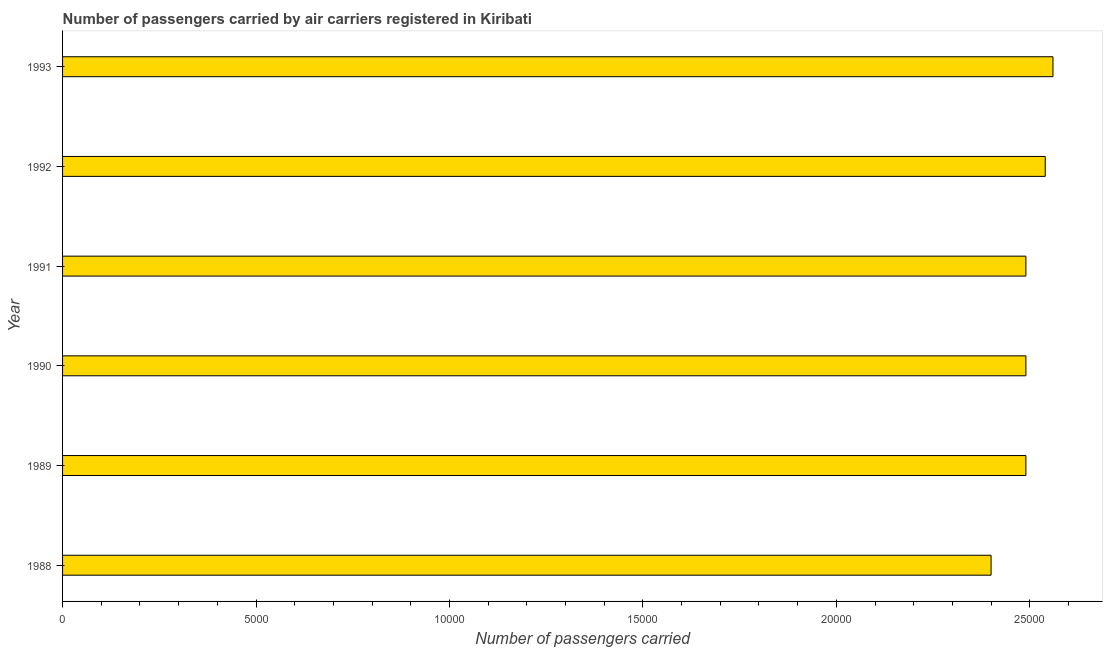Does the graph contain any zero values?
Your answer should be very brief. No. What is the title of the graph?
Provide a succinct answer. Number of passengers carried by air carriers registered in Kiribati. What is the label or title of the X-axis?
Your answer should be very brief. Number of passengers carried. What is the number of passengers carried in 1990?
Offer a very short reply. 2.49e+04. Across all years, what is the maximum number of passengers carried?
Give a very brief answer. 2.56e+04. Across all years, what is the minimum number of passengers carried?
Offer a very short reply. 2.40e+04. In which year was the number of passengers carried maximum?
Make the answer very short. 1993. What is the sum of the number of passengers carried?
Offer a terse response. 1.50e+05. What is the difference between the number of passengers carried in 1992 and 1993?
Offer a terse response. -200. What is the average number of passengers carried per year?
Provide a short and direct response. 2.50e+04. What is the median number of passengers carried?
Offer a terse response. 2.49e+04. In how many years, is the number of passengers carried greater than 11000 ?
Keep it short and to the point. 6. Is the number of passengers carried in 1989 less than that in 1992?
Make the answer very short. Yes. What is the difference between the highest and the lowest number of passengers carried?
Offer a very short reply. 1600. In how many years, is the number of passengers carried greater than the average number of passengers carried taken over all years?
Your response must be concise. 2. What is the difference between two consecutive major ticks on the X-axis?
Your answer should be compact. 5000. Are the values on the major ticks of X-axis written in scientific E-notation?
Provide a short and direct response. No. What is the Number of passengers carried of 1988?
Offer a very short reply. 2.40e+04. What is the Number of passengers carried in 1989?
Keep it short and to the point. 2.49e+04. What is the Number of passengers carried in 1990?
Make the answer very short. 2.49e+04. What is the Number of passengers carried of 1991?
Offer a very short reply. 2.49e+04. What is the Number of passengers carried in 1992?
Offer a very short reply. 2.54e+04. What is the Number of passengers carried of 1993?
Give a very brief answer. 2.56e+04. What is the difference between the Number of passengers carried in 1988 and 1989?
Your answer should be very brief. -900. What is the difference between the Number of passengers carried in 1988 and 1990?
Make the answer very short. -900. What is the difference between the Number of passengers carried in 1988 and 1991?
Provide a succinct answer. -900. What is the difference between the Number of passengers carried in 1988 and 1992?
Your response must be concise. -1400. What is the difference between the Number of passengers carried in 1988 and 1993?
Make the answer very short. -1600. What is the difference between the Number of passengers carried in 1989 and 1990?
Your answer should be compact. 0. What is the difference between the Number of passengers carried in 1989 and 1992?
Your response must be concise. -500. What is the difference between the Number of passengers carried in 1989 and 1993?
Make the answer very short. -700. What is the difference between the Number of passengers carried in 1990 and 1992?
Provide a short and direct response. -500. What is the difference between the Number of passengers carried in 1990 and 1993?
Your response must be concise. -700. What is the difference between the Number of passengers carried in 1991 and 1992?
Your answer should be very brief. -500. What is the difference between the Number of passengers carried in 1991 and 1993?
Your answer should be compact. -700. What is the difference between the Number of passengers carried in 1992 and 1993?
Make the answer very short. -200. What is the ratio of the Number of passengers carried in 1988 to that in 1989?
Your response must be concise. 0.96. What is the ratio of the Number of passengers carried in 1988 to that in 1990?
Provide a short and direct response. 0.96. What is the ratio of the Number of passengers carried in 1988 to that in 1991?
Provide a short and direct response. 0.96. What is the ratio of the Number of passengers carried in 1988 to that in 1992?
Give a very brief answer. 0.94. What is the ratio of the Number of passengers carried in 1988 to that in 1993?
Ensure brevity in your answer.  0.94. What is the ratio of the Number of passengers carried in 1989 to that in 1990?
Make the answer very short. 1. What is the ratio of the Number of passengers carried in 1989 to that in 1991?
Keep it short and to the point. 1. What is the ratio of the Number of passengers carried in 1989 to that in 1992?
Your response must be concise. 0.98. What is the ratio of the Number of passengers carried in 1989 to that in 1993?
Provide a short and direct response. 0.97. What is the ratio of the Number of passengers carried in 1990 to that in 1991?
Make the answer very short. 1. What is the ratio of the Number of passengers carried in 1990 to that in 1992?
Your answer should be very brief. 0.98. What is the ratio of the Number of passengers carried in 1990 to that in 1993?
Give a very brief answer. 0.97. What is the ratio of the Number of passengers carried in 1991 to that in 1992?
Give a very brief answer. 0.98. What is the ratio of the Number of passengers carried in 1991 to that in 1993?
Offer a terse response. 0.97. What is the ratio of the Number of passengers carried in 1992 to that in 1993?
Your answer should be compact. 0.99. 